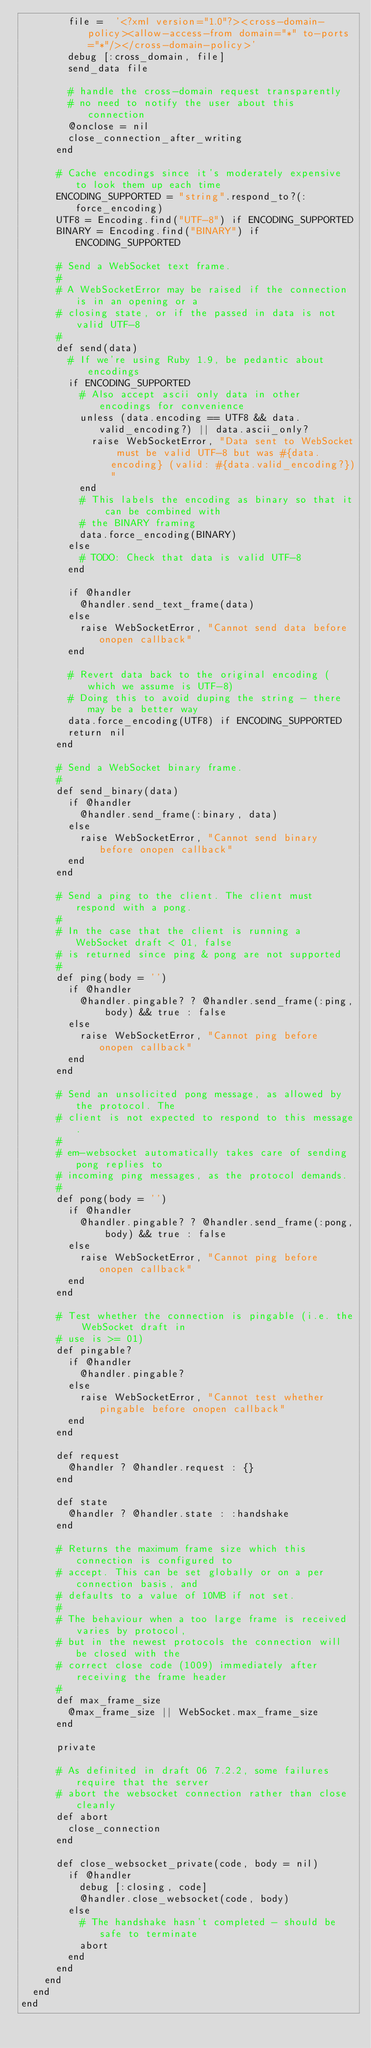<code> <loc_0><loc_0><loc_500><loc_500><_Ruby_>        file =  '<?xml version="1.0"?><cross-domain-policy><allow-access-from domain="*" to-ports="*"/></cross-domain-policy>'
        debug [:cross_domain, file]
        send_data file

        # handle the cross-domain request transparently
        # no need to notify the user about this connection
        @onclose = nil
        close_connection_after_writing
      end

      # Cache encodings since it's moderately expensive to look them up each time
      ENCODING_SUPPORTED = "string".respond_to?(:force_encoding)
      UTF8 = Encoding.find("UTF-8") if ENCODING_SUPPORTED
      BINARY = Encoding.find("BINARY") if ENCODING_SUPPORTED

      # Send a WebSocket text frame.
      #
      # A WebSocketError may be raised if the connection is in an opening or a
      # closing state, or if the passed in data is not valid UTF-8
      #
      def send(data)
        # If we're using Ruby 1.9, be pedantic about encodings
        if ENCODING_SUPPORTED
          # Also accept ascii only data in other encodings for convenience
          unless (data.encoding == UTF8 && data.valid_encoding?) || data.ascii_only?
            raise WebSocketError, "Data sent to WebSocket must be valid UTF-8 but was #{data.encoding} (valid: #{data.valid_encoding?})"
          end
          # This labels the encoding as binary so that it can be combined with
          # the BINARY framing
          data.force_encoding(BINARY)
        else
          # TODO: Check that data is valid UTF-8
        end

        if @handler
          @handler.send_text_frame(data)
        else
          raise WebSocketError, "Cannot send data before onopen callback"
        end

        # Revert data back to the original encoding (which we assume is UTF-8)
        # Doing this to avoid duping the string - there may be a better way
        data.force_encoding(UTF8) if ENCODING_SUPPORTED
        return nil
      end

      # Send a WebSocket binary frame.
      #
      def send_binary(data)
        if @handler
          @handler.send_frame(:binary, data)
        else
          raise WebSocketError, "Cannot send binary before onopen callback"
        end
      end

      # Send a ping to the client. The client must respond with a pong.
      #
      # In the case that the client is running a WebSocket draft < 01, false
      # is returned since ping & pong are not supported
      #
      def ping(body = '')
        if @handler
          @handler.pingable? ? @handler.send_frame(:ping, body) && true : false
        else
          raise WebSocketError, "Cannot ping before onopen callback"
        end
      end

      # Send an unsolicited pong message, as allowed by the protocol. The
      # client is not expected to respond to this message.
      #
      # em-websocket automatically takes care of sending pong replies to
      # incoming ping messages, as the protocol demands.
      #
      def pong(body = '')
        if @handler
          @handler.pingable? ? @handler.send_frame(:pong, body) && true : false
        else
          raise WebSocketError, "Cannot ping before onopen callback"
        end
      end

      # Test whether the connection is pingable (i.e. the WebSocket draft in
      # use is >= 01)
      def pingable?
        if @handler
          @handler.pingable?
        else
          raise WebSocketError, "Cannot test whether pingable before onopen callback"
        end
      end

      def request
        @handler ? @handler.request : {}
      end

      def state
        @handler ? @handler.state : :handshake
      end

      # Returns the maximum frame size which this connection is configured to
      # accept. This can be set globally or on a per connection basis, and
      # defaults to a value of 10MB if not set.
      #
      # The behaviour when a too large frame is received varies by protocol,
      # but in the newest protocols the connection will be closed with the
      # correct close code (1009) immediately after receiving the frame header
      #
      def max_frame_size
        @max_frame_size || WebSocket.max_frame_size
      end

      private

      # As definited in draft 06 7.2.2, some failures require that the server
      # abort the websocket connection rather than close cleanly
      def abort
        close_connection
      end

      def close_websocket_private(code, body = nil)
        if @handler
          debug [:closing, code]
          @handler.close_websocket(code, body)
        else
          # The handshake hasn't completed - should be safe to terminate
          abort
        end
      end
    end
  end
end
</code> 